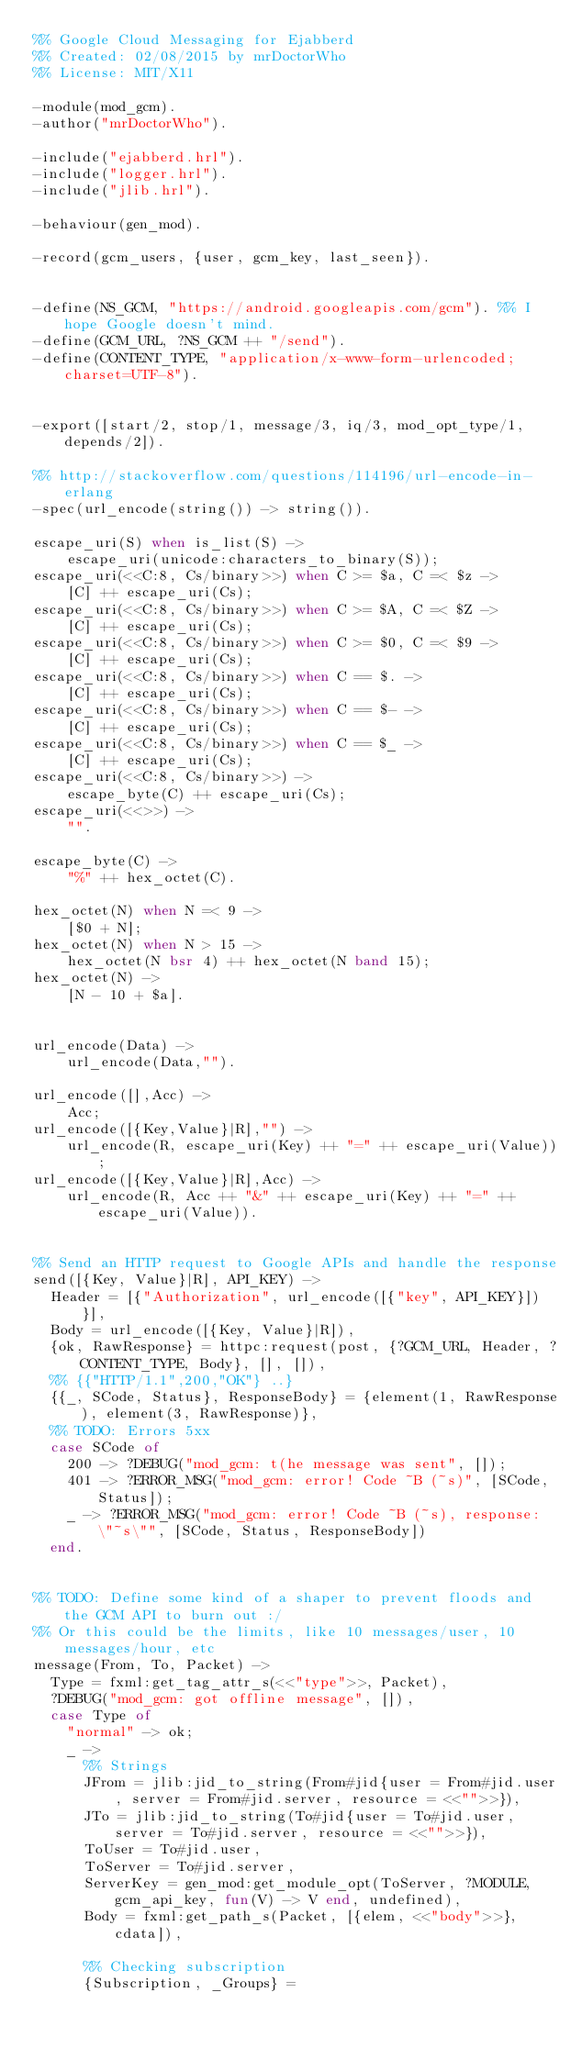<code> <loc_0><loc_0><loc_500><loc_500><_Erlang_>%% Google Cloud Messaging for Ejabberd
%% Created: 02/08/2015 by mrDoctorWho
%% License: MIT/X11

-module(mod_gcm).
-author("mrDoctorWho").

-include("ejabberd.hrl").
-include("logger.hrl").
-include("jlib.hrl").

-behaviour(gen_mod).

-record(gcm_users, {user, gcm_key, last_seen}).


-define(NS_GCM, "https://android.googleapis.com/gcm"). %% I hope Google doesn't mind.
-define(GCM_URL, ?NS_GCM ++ "/send").
-define(CONTENT_TYPE, "application/x-www-form-urlencoded;charset=UTF-8").


-export([start/2, stop/1, message/3, iq/3, mod_opt_type/1, depends/2]).

%% http://stackoverflow.com/questions/114196/url-encode-in-erlang
-spec(url_encode(string()) -> string()).

escape_uri(S) when is_list(S) ->
    escape_uri(unicode:characters_to_binary(S));
escape_uri(<<C:8, Cs/binary>>) when C >= $a, C =< $z ->
    [C] ++ escape_uri(Cs);
escape_uri(<<C:8, Cs/binary>>) when C >= $A, C =< $Z ->
    [C] ++ escape_uri(Cs);
escape_uri(<<C:8, Cs/binary>>) when C >= $0, C =< $9 ->
    [C] ++ escape_uri(Cs);
escape_uri(<<C:8, Cs/binary>>) when C == $. ->
    [C] ++ escape_uri(Cs);
escape_uri(<<C:8, Cs/binary>>) when C == $- ->
    [C] ++ escape_uri(Cs);
escape_uri(<<C:8, Cs/binary>>) when C == $_ ->
    [C] ++ escape_uri(Cs);
escape_uri(<<C:8, Cs/binary>>) ->
    escape_byte(C) ++ escape_uri(Cs);
escape_uri(<<>>) ->
    "".

escape_byte(C) ->
    "%" ++ hex_octet(C).

hex_octet(N) when N =< 9 ->
    [$0 + N];
hex_octet(N) when N > 15 ->
    hex_octet(N bsr 4) ++ hex_octet(N band 15);
hex_octet(N) ->
    [N - 10 + $a].


url_encode(Data) ->
    url_encode(Data,"").

url_encode([],Acc) ->
    Acc;
url_encode([{Key,Value}|R],"") ->
    url_encode(R, escape_uri(Key) ++ "=" ++ escape_uri(Value));
url_encode([{Key,Value}|R],Acc) ->
    url_encode(R, Acc ++ "&" ++ escape_uri(Key) ++ "=" ++ escape_uri(Value)).


%% Send an HTTP request to Google APIs and handle the response
send([{Key, Value}|R], API_KEY) ->
	Header = [{"Authorization", url_encode([{"key", API_KEY}])}],
	Body = url_encode([{Key, Value}|R]),
	{ok, RawResponse} = httpc:request(post, {?GCM_URL, Header, ?CONTENT_TYPE, Body}, [], []),
	%% {{"HTTP/1.1",200,"OK"} ..}
	{{_, SCode, Status}, ResponseBody} = {element(1, RawResponse), element(3, RawResponse)},
	%% TODO: Errors 5xx
	case SCode of
		200 -> ?DEBUG("mod_gcm: t(he message was sent", []);
		401 -> ?ERROR_MSG("mod_gcm: error! Code ~B (~s)", [SCode, Status]);
		_ -> ?ERROR_MSG("mod_gcm: error! Code ~B (~s), response: \"~s\"", [SCode, Status, ResponseBody])
	end.


%% TODO: Define some kind of a shaper to prevent floods and the GCM API to burn out :/
%% Or this could be the limits, like 10 messages/user, 10 messages/hour, etc
message(From, To, Packet) ->
	Type = fxml:get_tag_attr_s(<<"type">>, Packet),
	?DEBUG("mod_gcm: got offline message", []),
	case Type of 
		"normal" -> ok;
		_ ->
			%% Strings
			JFrom = jlib:jid_to_string(From#jid{user = From#jid.user, server = From#jid.server, resource = <<"">>}),
			JTo = jlib:jid_to_string(To#jid{user = To#jid.user, server = To#jid.server, resource = <<"">>}),
			ToUser = To#jid.user,
			ToServer = To#jid.server,
			ServerKey = gen_mod:get_module_opt(ToServer, ?MODULE, gcm_api_key, fun(V) -> V end, undefined),
			Body = fxml:get_path_s(Packet, [{elem, <<"body">>}, cdata]),

			%% Checking subscription
			{Subscription, _Groups} = </code> 